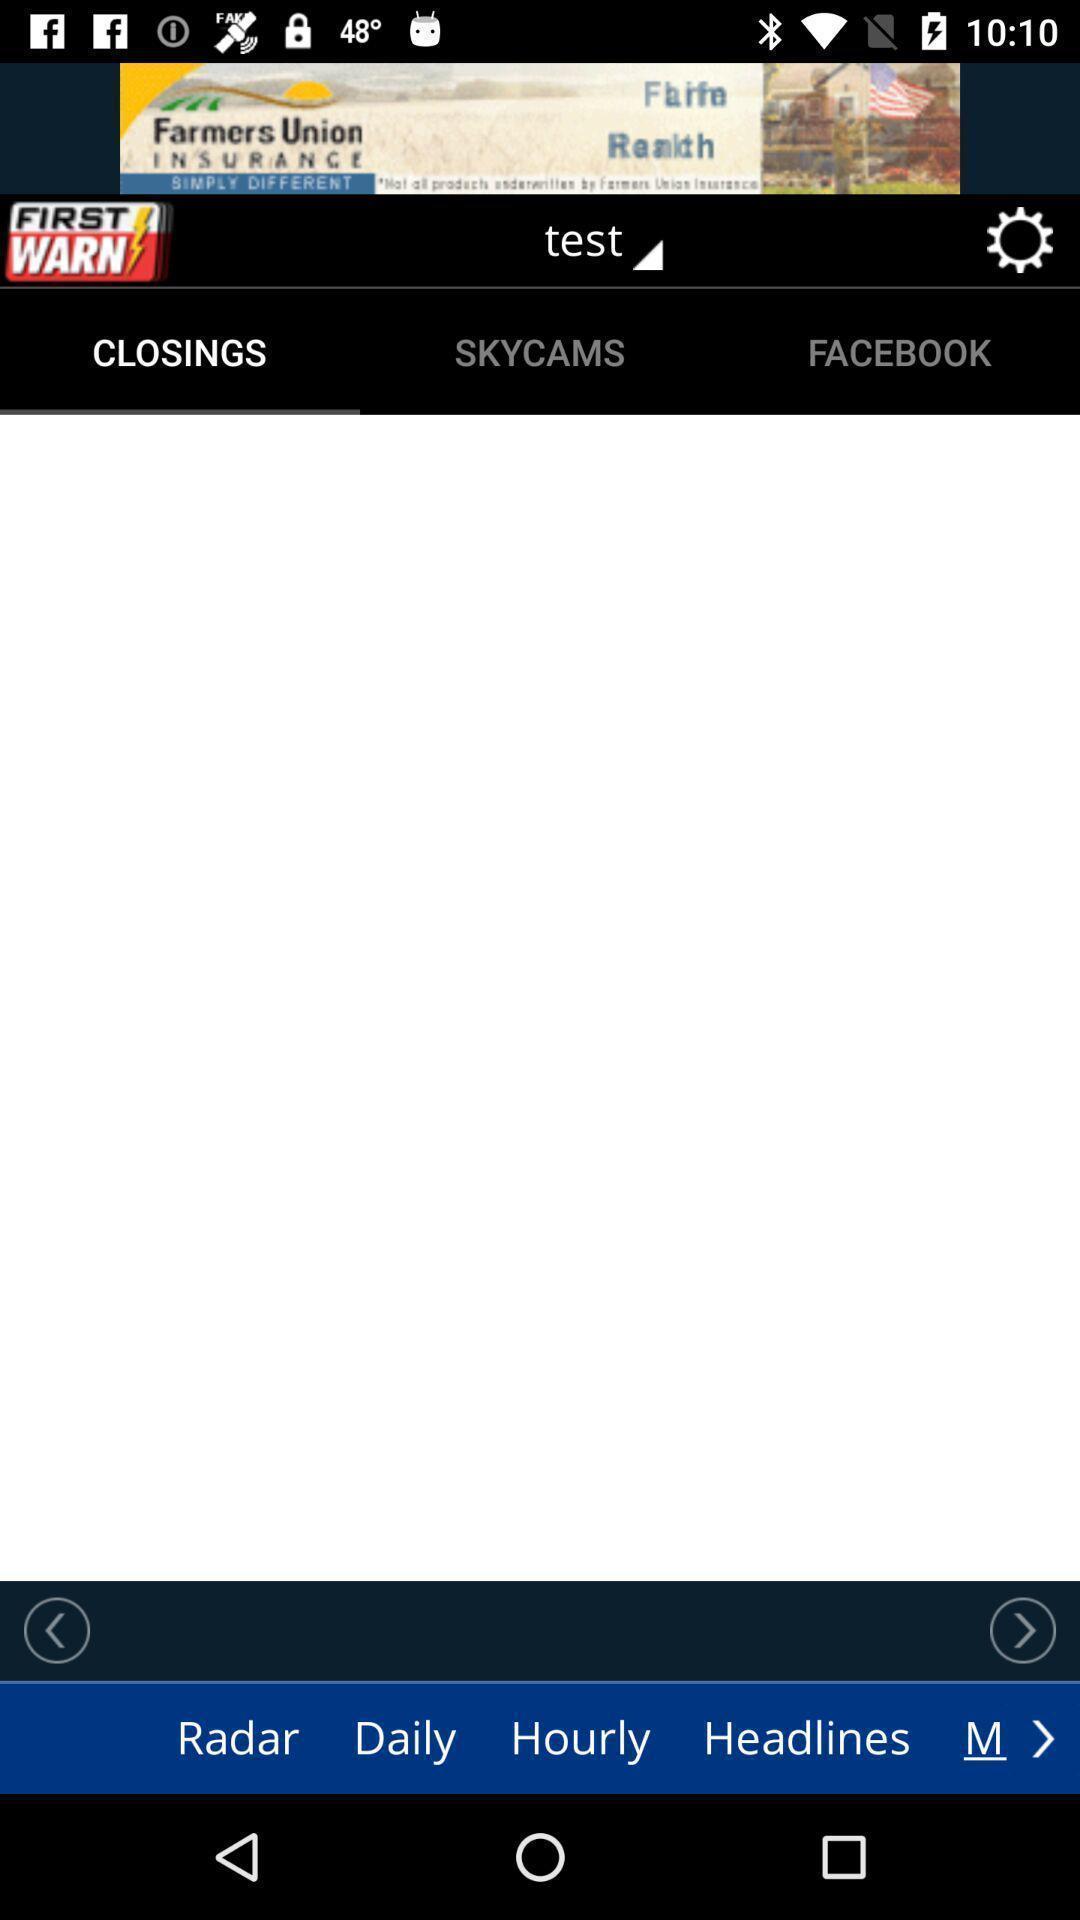Summarize the main components in this picture. Welcome page. 